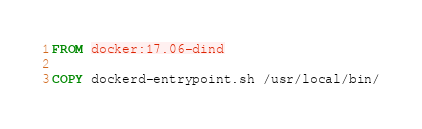<code> <loc_0><loc_0><loc_500><loc_500><_Dockerfile_>FROM docker:17.06-dind

COPY dockerd-entrypoint.sh /usr/local/bin/
</code> 